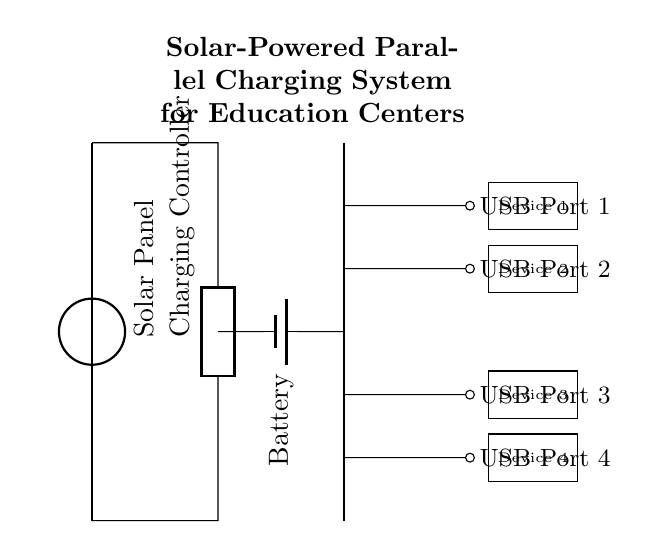What is the primary power source for this circuit? The circuit is powered by a solar panel, which is indicated at the top of the diagram.
Answer: Solar Panel How many USB charging ports are present? The diagram shows four separate USB ports, each connected in parallel to the main power bus, indicated by the lines branching out from the battery.
Answer: Four What is the role of the charging controller in this circuit? The charging controller is responsible for regulating the voltage and current from the solar panel to the battery and devices, which is shown as a generic component near the center of the diagram.
Answer: Regulator How are the devices connected to the circuit? The devices are connected parallelly via the USB ports, allowing each device to receive power independently, as shown by the separate branches leading to each device.
Answer: Parallelly What type of battery is used in this circuit? The battery type shown is a "battery1" component, which indicates a specific battery type but does not specify the chemistry. However, it supports the storage of solar energy generated.
Answer: Battery 